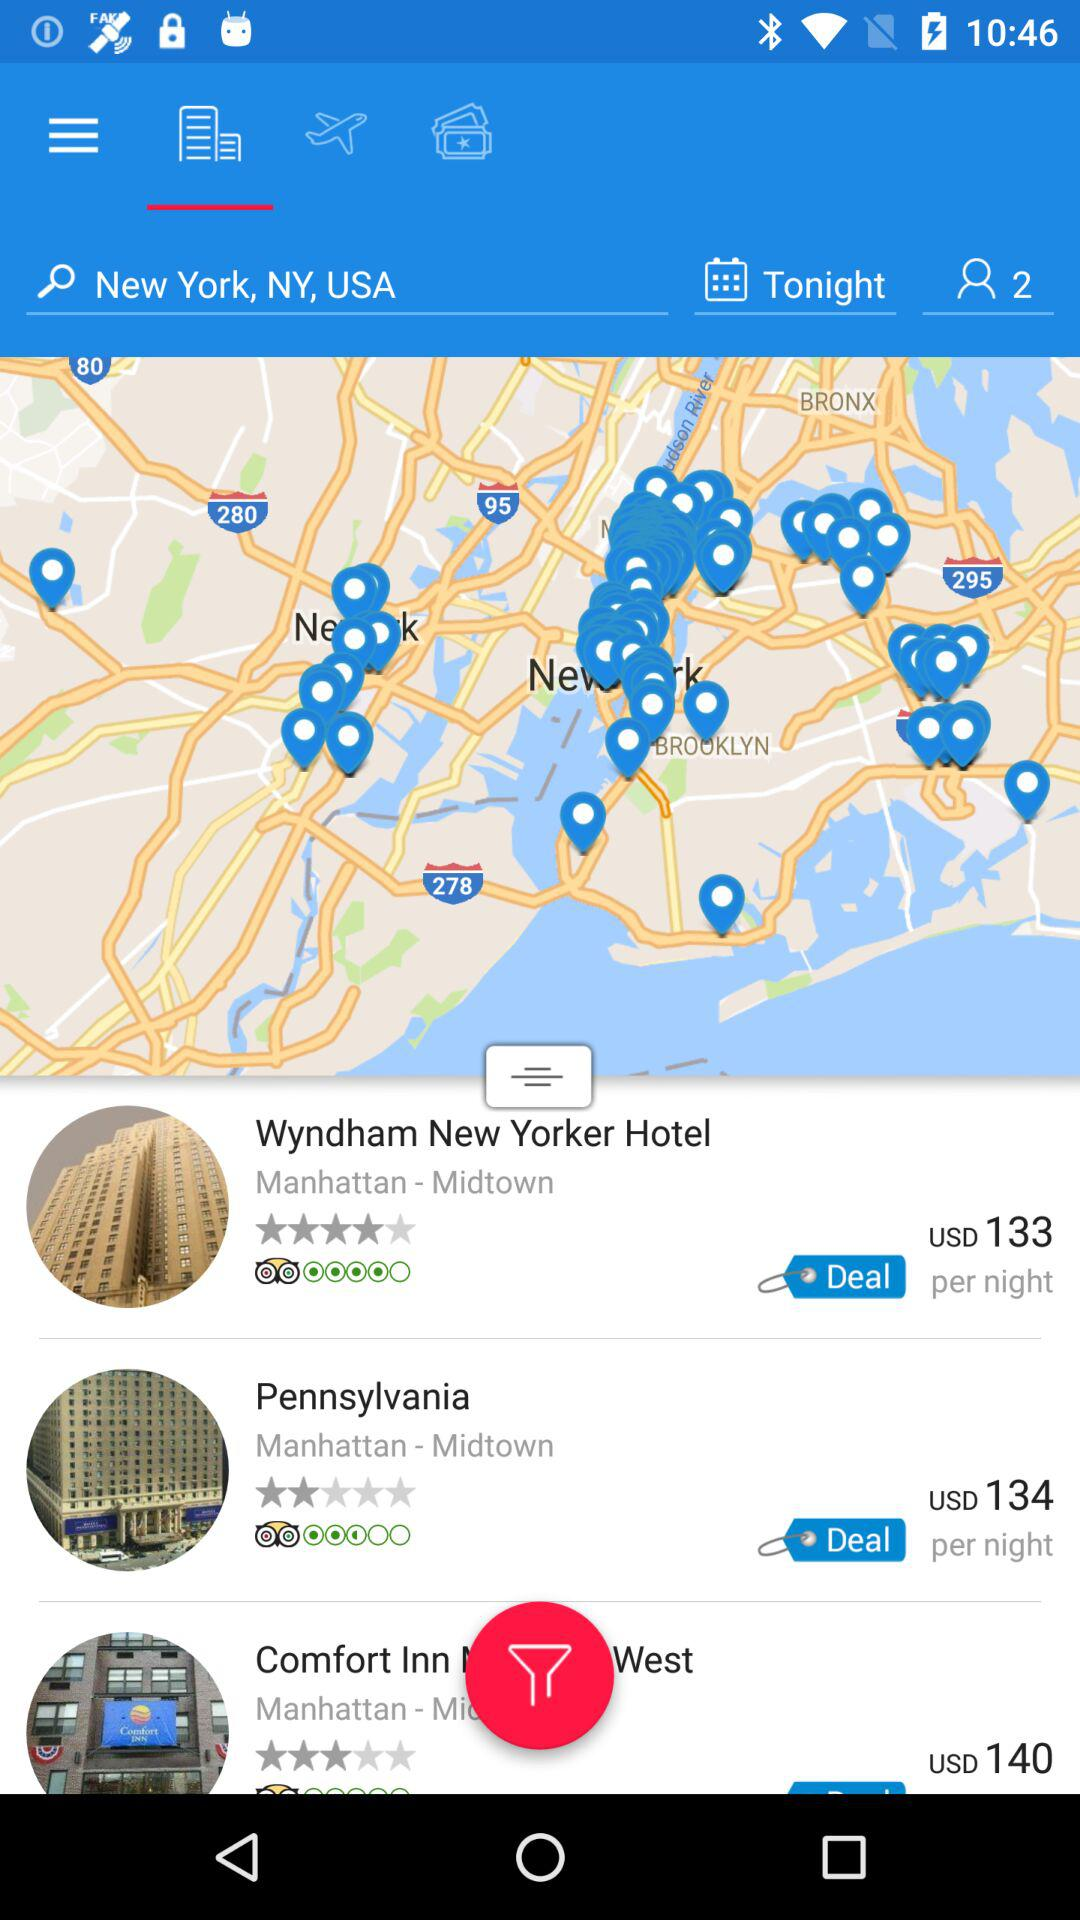What is the booking price of a room at the "Wyndham New Yorker Hotel"? The booking price of a room at the "Wyndham New Yorker Hotel" is 133 US dollars per night. 